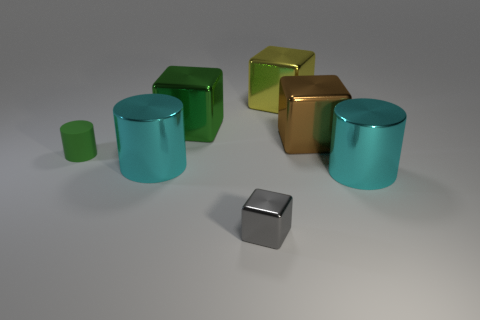Are there any shiny things that have the same color as the matte thing?
Give a very brief answer. Yes. Is the number of tiny gray shiny cubes in front of the large green metallic thing less than the number of purple cylinders?
Provide a succinct answer. No. What is the tiny thing to the right of the tiny matte object made of?
Your answer should be compact. Metal. How many other objects are the same size as the yellow object?
Offer a terse response. 4. Are there fewer gray shiny things than shiny cylinders?
Make the answer very short. Yes. The large yellow metallic thing has what shape?
Give a very brief answer. Cube. Do the big metallic cube that is left of the big yellow thing and the tiny cylinder have the same color?
Your answer should be compact. Yes. There is a shiny object that is both behind the green cylinder and to the right of the yellow block; what shape is it?
Provide a short and direct response. Cube. What color is the tiny thing that is in front of the small green matte cylinder?
Keep it short and to the point. Gray. Is there any other thing that is the same color as the small rubber object?
Your answer should be compact. Yes. 